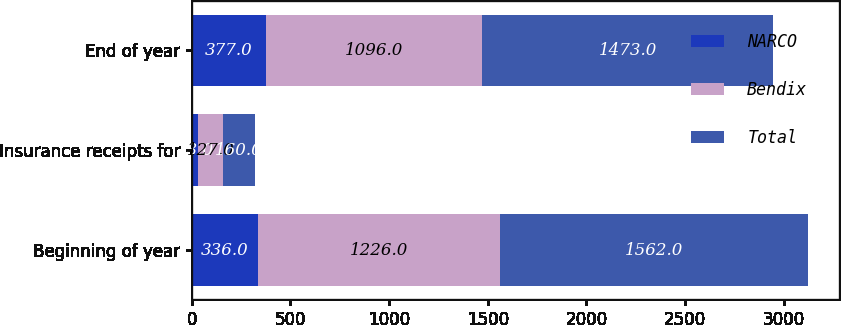Convert chart. <chart><loc_0><loc_0><loc_500><loc_500><stacked_bar_chart><ecel><fcel>Beginning of year<fcel>Insurance receipts for<fcel>End of year<nl><fcel>NARCO<fcel>336<fcel>33<fcel>377<nl><fcel>Bendix<fcel>1226<fcel>127<fcel>1096<nl><fcel>Total<fcel>1562<fcel>160<fcel>1473<nl></chart> 